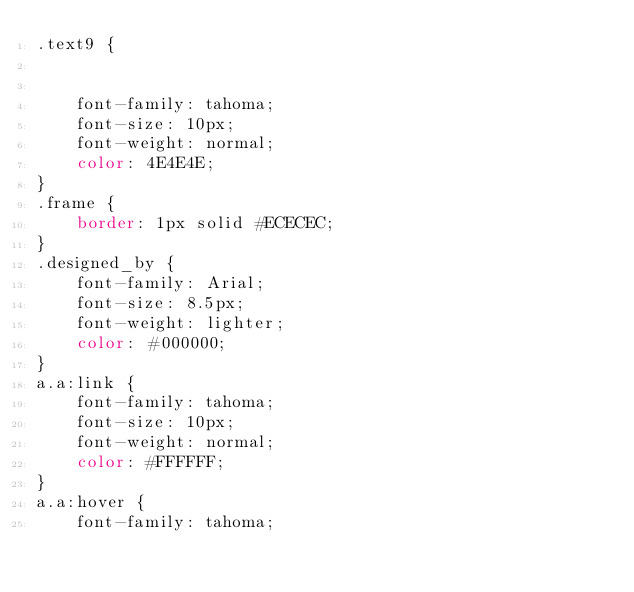<code> <loc_0><loc_0><loc_500><loc_500><_CSS_>.text9 {


	font-family: tahoma;
	font-size: 10px;
	font-weight: normal;
	color: 4E4E4E;
}
.frame {
	border: 1px solid #ECECEC;
}
.designed_by {
	font-family: Arial;
	font-size: 8.5px;
	font-weight: lighter;
	color: #000000;
}
a.a:link {
	font-family: tahoma;
	font-size: 10px;
	font-weight: normal;
	color: #FFFFFF;
}
a.a:hover {
	font-family: tahoma;</code> 